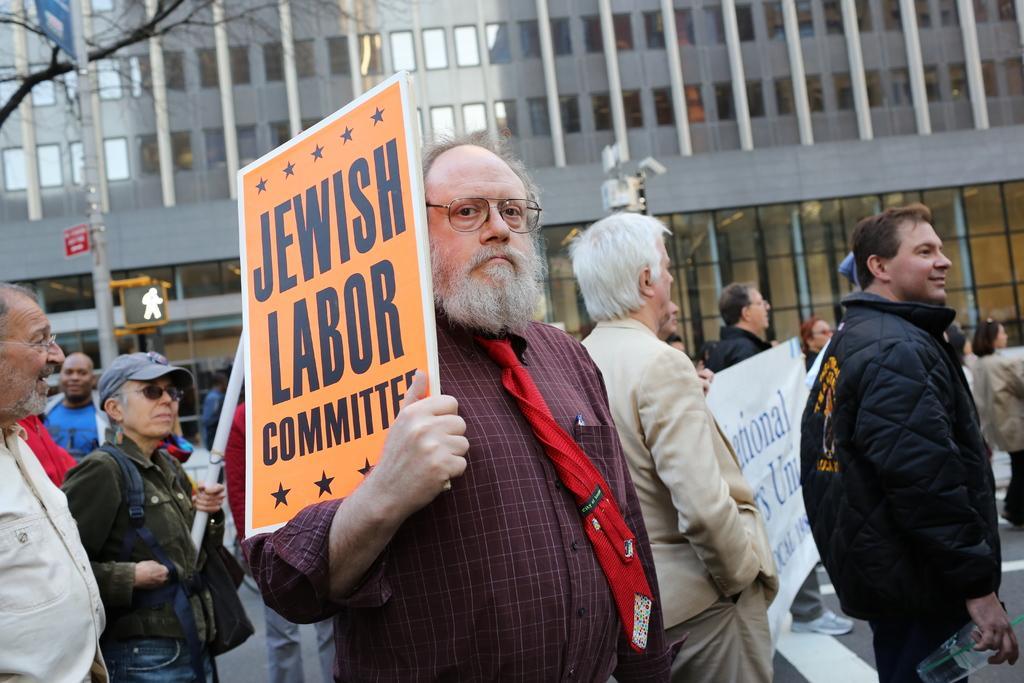Please provide a concise description of this image. This picture describes about group of people, few people holding a banner, in the background we can see a building, few sign boards and a tree, in the middle of the image we can see a man, he is holding a placard. 